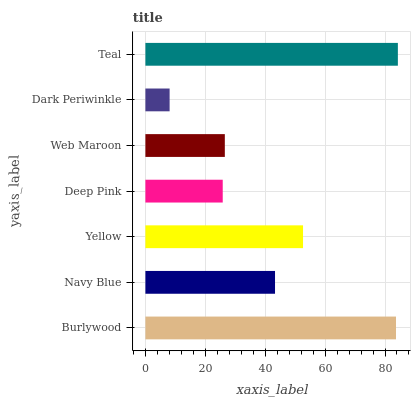Is Dark Periwinkle the minimum?
Answer yes or no. Yes. Is Teal the maximum?
Answer yes or no. Yes. Is Navy Blue the minimum?
Answer yes or no. No. Is Navy Blue the maximum?
Answer yes or no. No. Is Burlywood greater than Navy Blue?
Answer yes or no. Yes. Is Navy Blue less than Burlywood?
Answer yes or no. Yes. Is Navy Blue greater than Burlywood?
Answer yes or no. No. Is Burlywood less than Navy Blue?
Answer yes or no. No. Is Navy Blue the high median?
Answer yes or no. Yes. Is Navy Blue the low median?
Answer yes or no. Yes. Is Teal the high median?
Answer yes or no. No. Is Teal the low median?
Answer yes or no. No. 